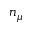<formula> <loc_0><loc_0><loc_500><loc_500>n _ { \mu }</formula> 